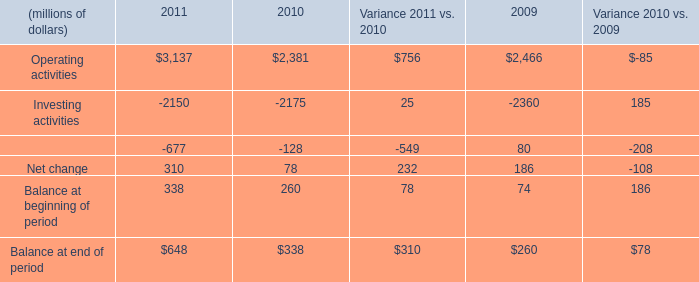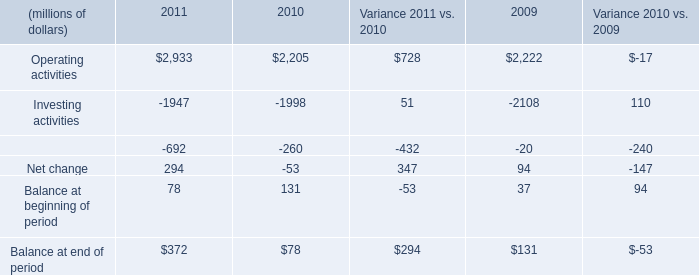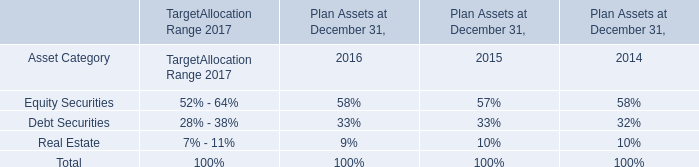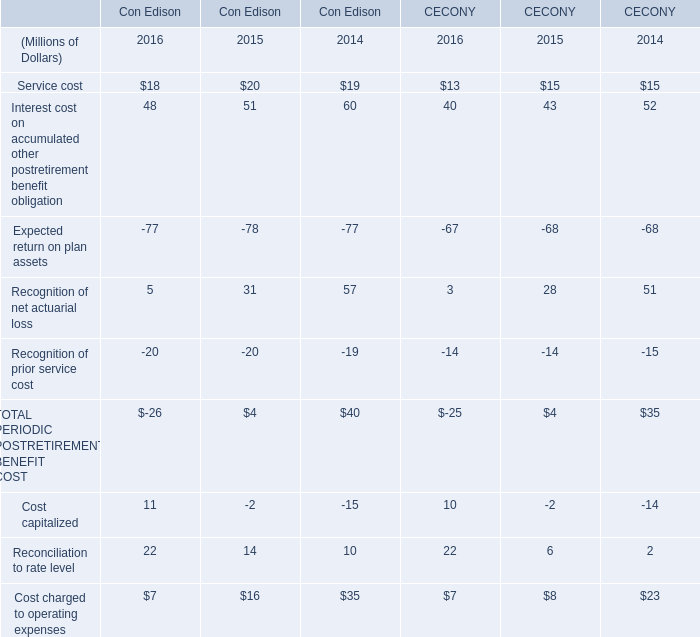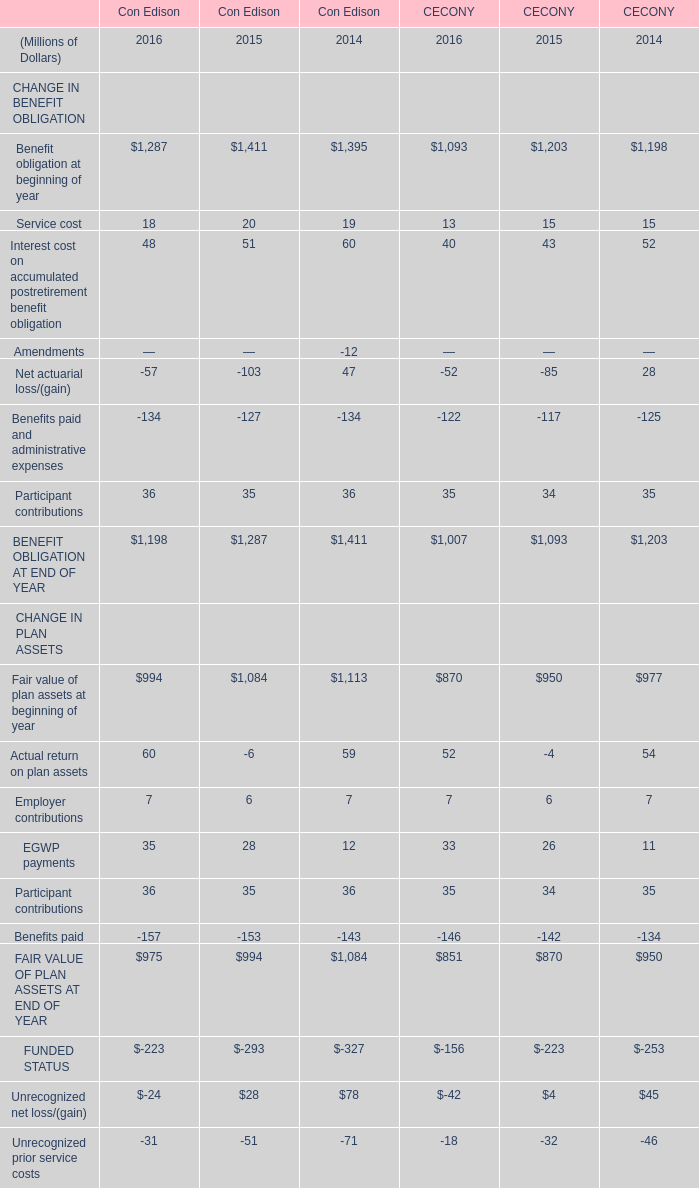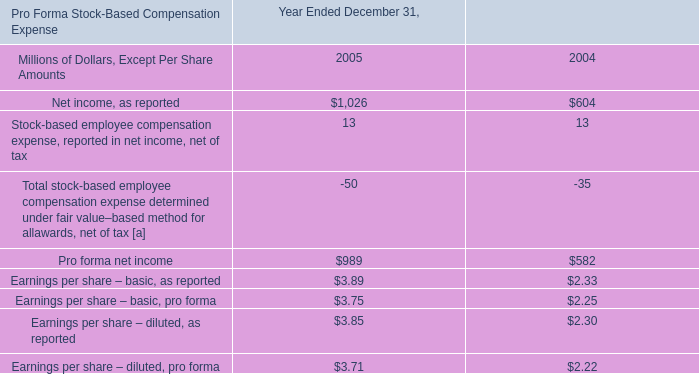Which year the Reconciliation to rate level of Con Edison is the highest? 
Answer: 2016. 